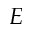<formula> <loc_0><loc_0><loc_500><loc_500>E</formula> 